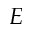<formula> <loc_0><loc_0><loc_500><loc_500>E</formula> 